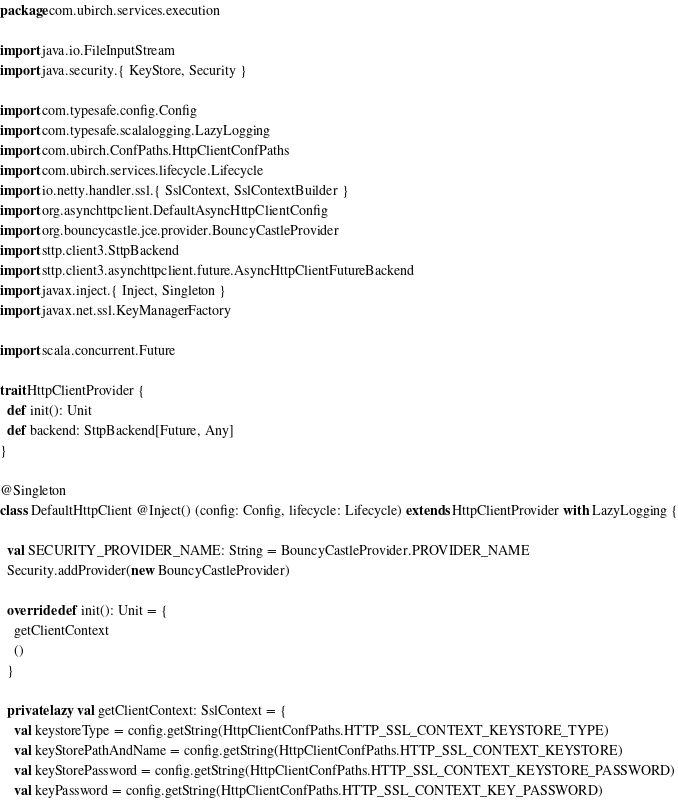<code> <loc_0><loc_0><loc_500><loc_500><_Scala_>package com.ubirch.services.execution

import java.io.FileInputStream
import java.security.{ KeyStore, Security }

import com.typesafe.config.Config
import com.typesafe.scalalogging.LazyLogging
import com.ubirch.ConfPaths.HttpClientConfPaths
import com.ubirch.services.lifecycle.Lifecycle
import io.netty.handler.ssl.{ SslContext, SslContextBuilder }
import org.asynchttpclient.DefaultAsyncHttpClientConfig
import org.bouncycastle.jce.provider.BouncyCastleProvider
import sttp.client3.SttpBackend
import sttp.client3.asynchttpclient.future.AsyncHttpClientFutureBackend
import javax.inject.{ Inject, Singleton }
import javax.net.ssl.KeyManagerFactory

import scala.concurrent.Future

trait HttpClientProvider {
  def init(): Unit
  def backend: SttpBackend[Future, Any]
}

@Singleton
class DefaultHttpClient @Inject() (config: Config, lifecycle: Lifecycle) extends HttpClientProvider with LazyLogging {

  val SECURITY_PROVIDER_NAME: String = BouncyCastleProvider.PROVIDER_NAME
  Security.addProvider(new BouncyCastleProvider)

  override def init(): Unit = {
    getClientContext
    ()
  }

  private lazy val getClientContext: SslContext = {
    val keystoreType = config.getString(HttpClientConfPaths.HTTP_SSL_CONTEXT_KEYSTORE_TYPE)
    val keyStorePathAndName = config.getString(HttpClientConfPaths.HTTP_SSL_CONTEXT_KEYSTORE)
    val keyStorePassword = config.getString(HttpClientConfPaths.HTTP_SSL_CONTEXT_KEYSTORE_PASSWORD)
    val keyPassword = config.getString(HttpClientConfPaths.HTTP_SSL_CONTEXT_KEY_PASSWORD)
</code> 